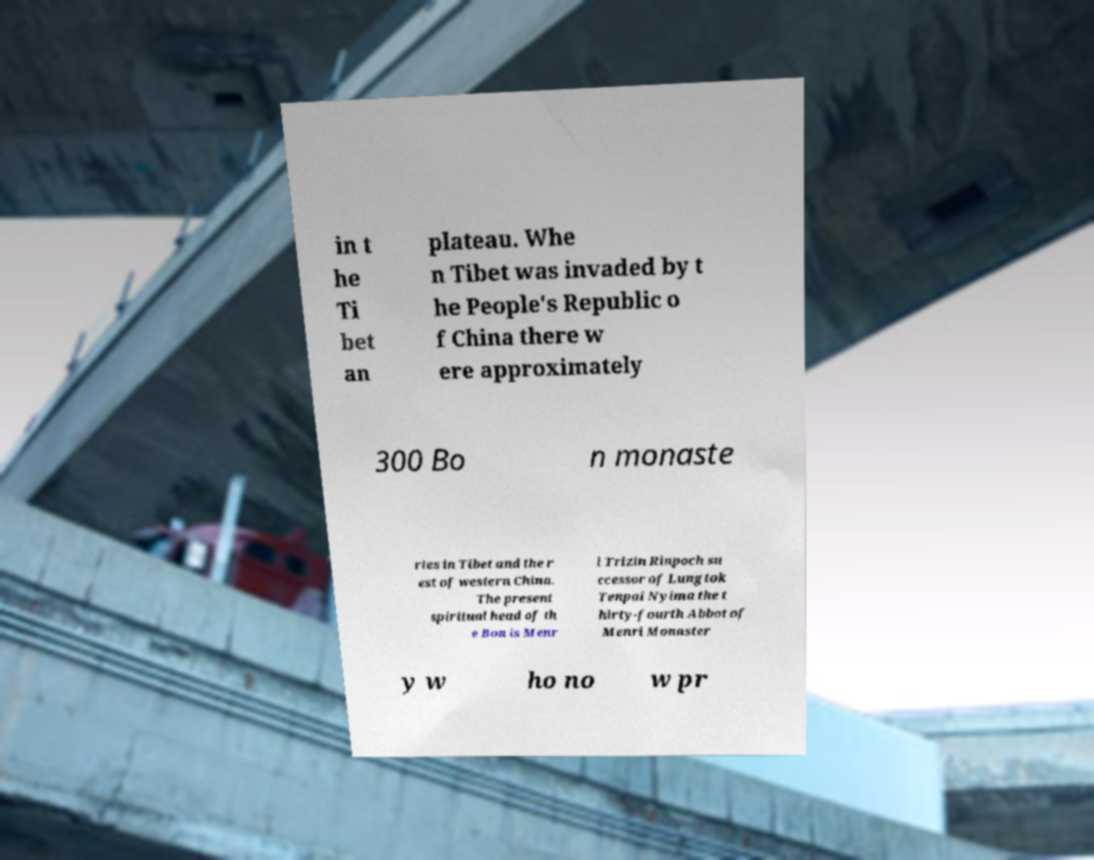Please read and relay the text visible in this image. What does it say? in t he Ti bet an plateau. Whe n Tibet was invaded by t he People's Republic o f China there w ere approximately 300 Bo n monaste ries in Tibet and the r est of western China. The present spiritual head of th e Bon is Menr i Trizin Rinpoch su ccessor of Lungtok Tenpai Nyima the t hirty-fourth Abbot of Menri Monaster y w ho no w pr 